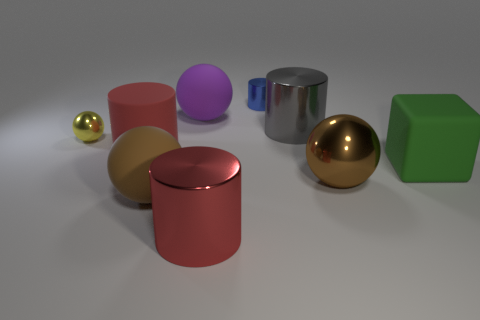What is the shape of the large matte thing that is behind the red matte cylinder? sphere 